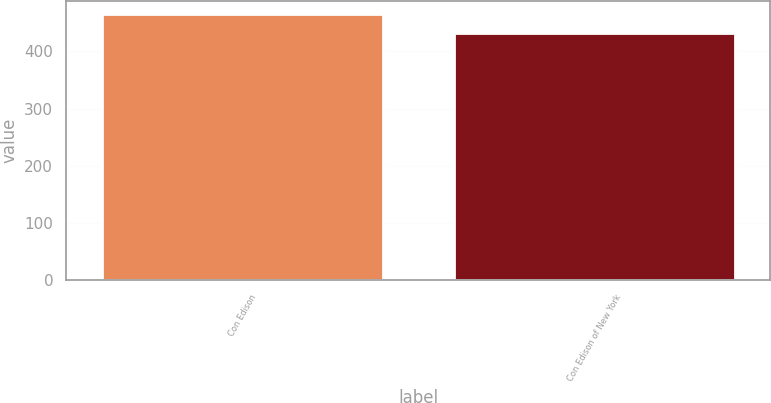Convert chart to OTSL. <chart><loc_0><loc_0><loc_500><loc_500><bar_chart><fcel>Con Edison<fcel>Con Edison of New York<nl><fcel>465<fcel>433<nl></chart> 